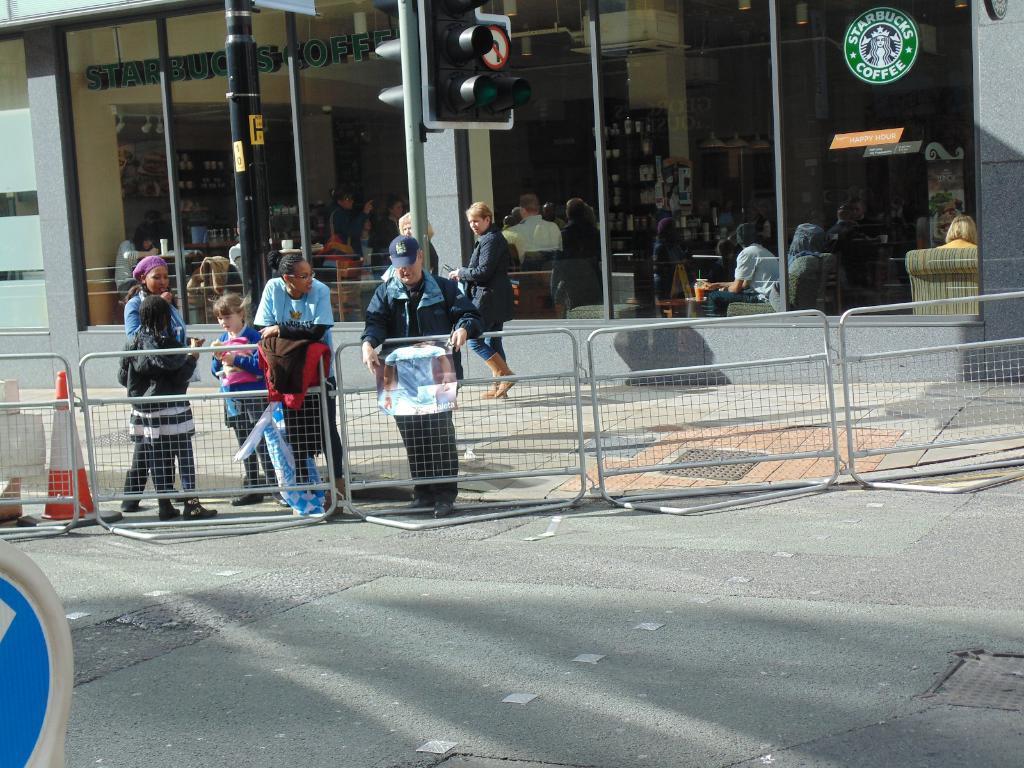Could you give a brief overview of what you see in this image? In this image I can see few people and traffic cone at the railing. I can see two poles. In the background I can see few more people are inside the building. To the left I can see the blue and cream color object. 